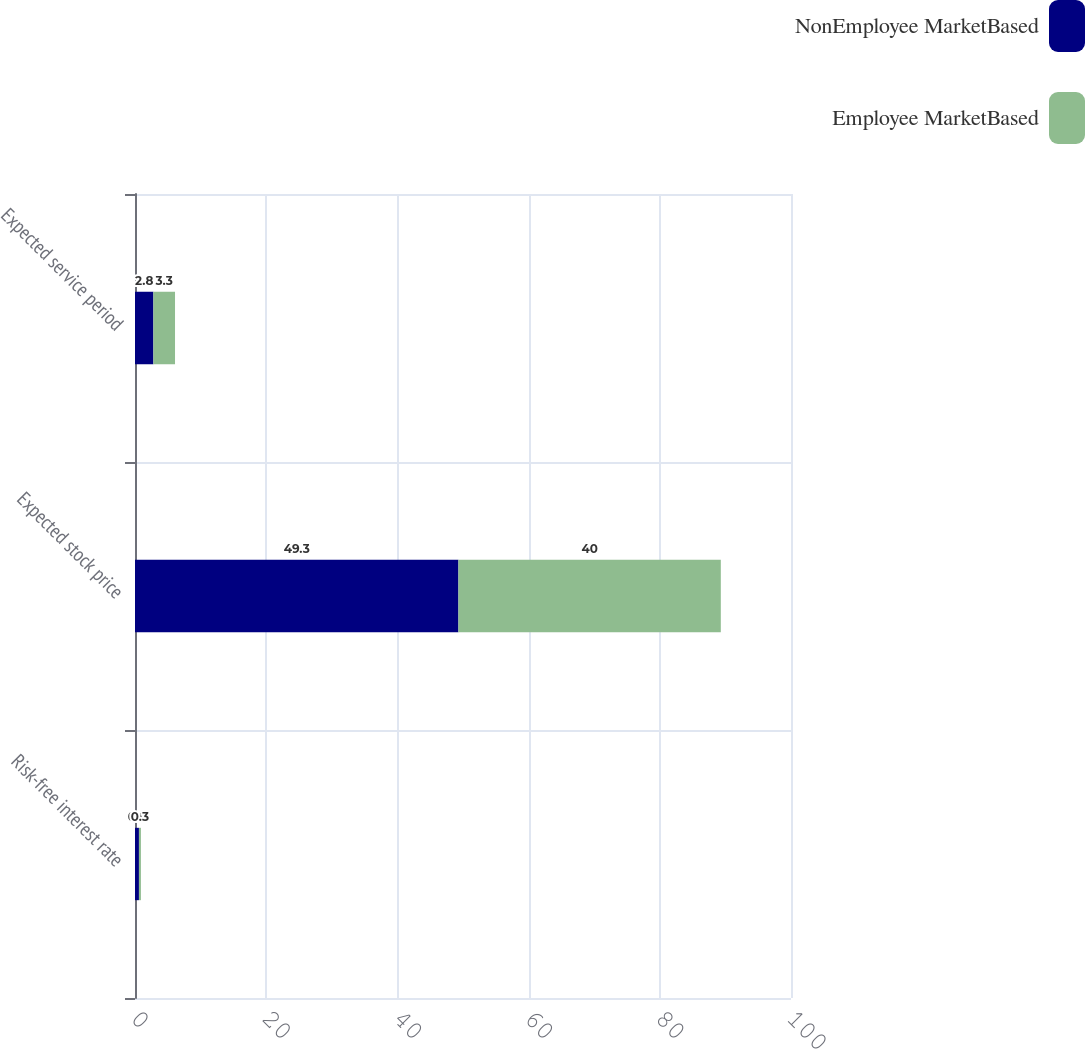Convert chart. <chart><loc_0><loc_0><loc_500><loc_500><stacked_bar_chart><ecel><fcel>Risk-free interest rate<fcel>Expected stock price<fcel>Expected service period<nl><fcel>NonEmployee MarketBased<fcel>0.6<fcel>49.3<fcel>2.8<nl><fcel>Employee MarketBased<fcel>0.3<fcel>40<fcel>3.3<nl></chart> 